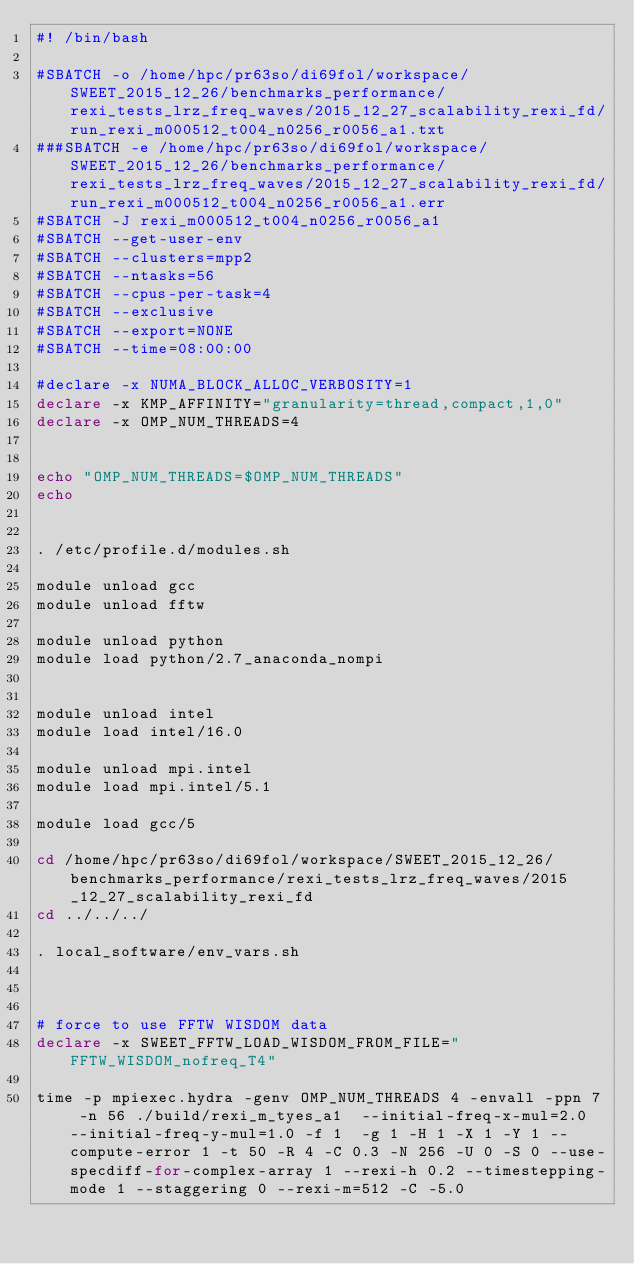Convert code to text. <code><loc_0><loc_0><loc_500><loc_500><_Bash_>#! /bin/bash

#SBATCH -o /home/hpc/pr63so/di69fol/workspace/SWEET_2015_12_26/benchmarks_performance/rexi_tests_lrz_freq_waves/2015_12_27_scalability_rexi_fd/run_rexi_m000512_t004_n0256_r0056_a1.txt
###SBATCH -e /home/hpc/pr63so/di69fol/workspace/SWEET_2015_12_26/benchmarks_performance/rexi_tests_lrz_freq_waves/2015_12_27_scalability_rexi_fd/run_rexi_m000512_t004_n0256_r0056_a1.err
#SBATCH -J rexi_m000512_t004_n0256_r0056_a1
#SBATCH --get-user-env
#SBATCH --clusters=mpp2
#SBATCH --ntasks=56
#SBATCH --cpus-per-task=4
#SBATCH --exclusive
#SBATCH --export=NONE
#SBATCH --time=08:00:00

#declare -x NUMA_BLOCK_ALLOC_VERBOSITY=1
declare -x KMP_AFFINITY="granularity=thread,compact,1,0"
declare -x OMP_NUM_THREADS=4


echo "OMP_NUM_THREADS=$OMP_NUM_THREADS"
echo


. /etc/profile.d/modules.sh

module unload gcc
module unload fftw

module unload python
module load python/2.7_anaconda_nompi


module unload intel
module load intel/16.0

module unload mpi.intel
module load mpi.intel/5.1

module load gcc/5

cd /home/hpc/pr63so/di69fol/workspace/SWEET_2015_12_26/benchmarks_performance/rexi_tests_lrz_freq_waves/2015_12_27_scalability_rexi_fd
cd ../../../

. local_software/env_vars.sh



# force to use FFTW WISDOM data
declare -x SWEET_FFTW_LOAD_WISDOM_FROM_FILE="FFTW_WISDOM_nofreq_T4"

time -p mpiexec.hydra -genv OMP_NUM_THREADS 4 -envall -ppn 7 -n 56 ./build/rexi_m_tyes_a1  --initial-freq-x-mul=2.0 --initial-freq-y-mul=1.0 -f 1  -g 1 -H 1 -X 1 -Y 1 --compute-error 1 -t 50 -R 4 -C 0.3 -N 256 -U 0 -S 0 --use-specdiff-for-complex-array 1 --rexi-h 0.2 --timestepping-mode 1 --staggering 0 --rexi-m=512 -C -5.0

</code> 